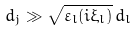Convert formula to latex. <formula><loc_0><loc_0><loc_500><loc_500>d _ { j } \gg \sqrt { \varepsilon _ { l } ( i \xi _ { l } ) } \, d _ { l }</formula> 